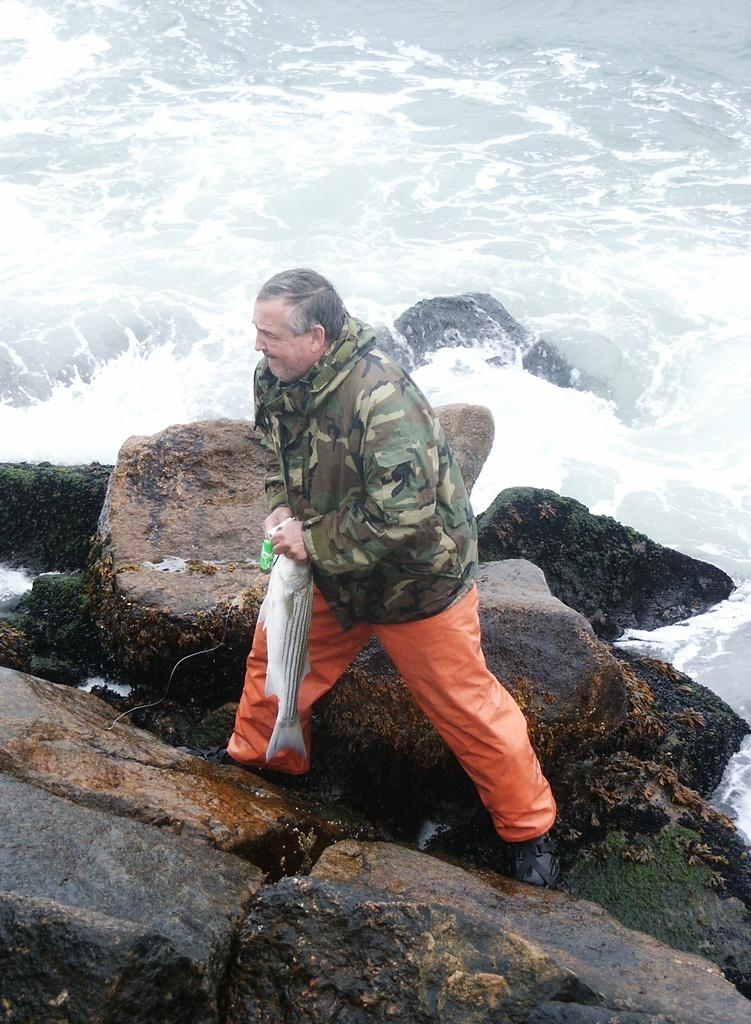Who is the main subject in the foreground of the picture? There is a man in the foreground of the picture. What is the man doing in the picture? The man is on a rock and holding a fish in his hand. What can be seen in the background of the picture? There are rocks and water visible in the background of the picture. What historical songs can be heard playing in the background of the image? There is no audio or music present in the image, so it is not possible to determine what songs might be heard. 